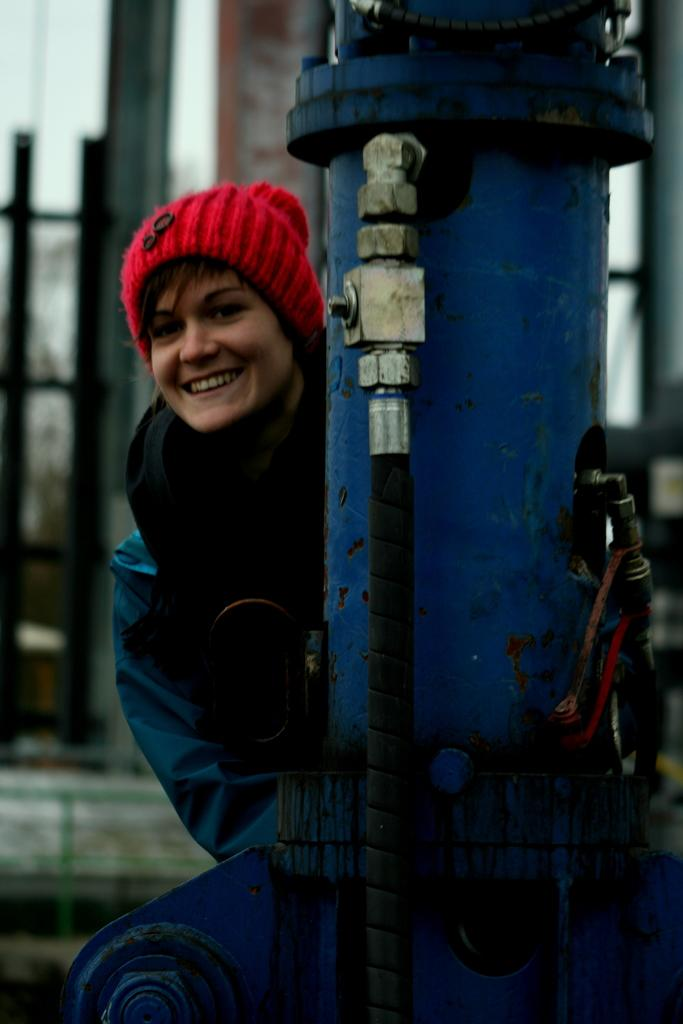What color is the object in the image? The object in the image is blue. Who is present in the image? There is a woman in the image. What is the woman's expression? The woman is smiling. How would you describe the background of the image? The background of the image appears blurred. What type of connection can be seen between the woman and the blue object in the image? There is no visible connection between the woman and the blue object in the image. Can you tell me how many grapes are on the woman's plate in the image? There is no plate or grapes present in the image. 